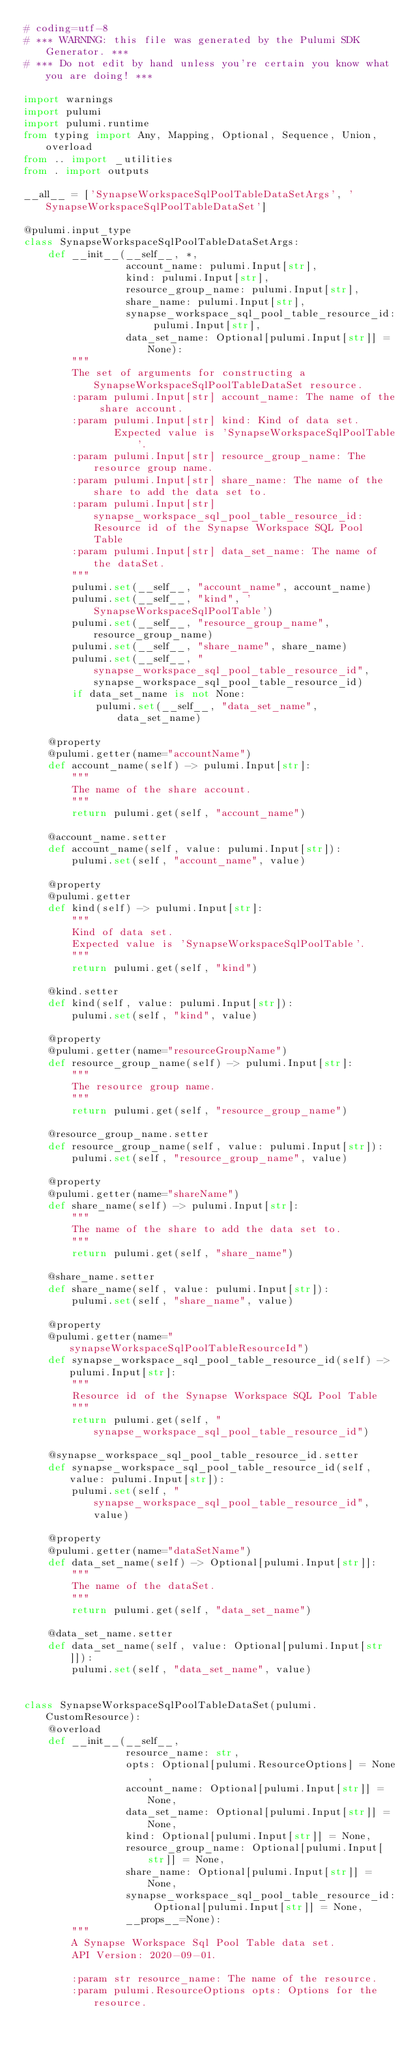Convert code to text. <code><loc_0><loc_0><loc_500><loc_500><_Python_># coding=utf-8
# *** WARNING: this file was generated by the Pulumi SDK Generator. ***
# *** Do not edit by hand unless you're certain you know what you are doing! ***

import warnings
import pulumi
import pulumi.runtime
from typing import Any, Mapping, Optional, Sequence, Union, overload
from .. import _utilities
from . import outputs

__all__ = ['SynapseWorkspaceSqlPoolTableDataSetArgs', 'SynapseWorkspaceSqlPoolTableDataSet']

@pulumi.input_type
class SynapseWorkspaceSqlPoolTableDataSetArgs:
    def __init__(__self__, *,
                 account_name: pulumi.Input[str],
                 kind: pulumi.Input[str],
                 resource_group_name: pulumi.Input[str],
                 share_name: pulumi.Input[str],
                 synapse_workspace_sql_pool_table_resource_id: pulumi.Input[str],
                 data_set_name: Optional[pulumi.Input[str]] = None):
        """
        The set of arguments for constructing a SynapseWorkspaceSqlPoolTableDataSet resource.
        :param pulumi.Input[str] account_name: The name of the share account.
        :param pulumi.Input[str] kind: Kind of data set.
               Expected value is 'SynapseWorkspaceSqlPoolTable'.
        :param pulumi.Input[str] resource_group_name: The resource group name.
        :param pulumi.Input[str] share_name: The name of the share to add the data set to.
        :param pulumi.Input[str] synapse_workspace_sql_pool_table_resource_id: Resource id of the Synapse Workspace SQL Pool Table
        :param pulumi.Input[str] data_set_name: The name of the dataSet.
        """
        pulumi.set(__self__, "account_name", account_name)
        pulumi.set(__self__, "kind", 'SynapseWorkspaceSqlPoolTable')
        pulumi.set(__self__, "resource_group_name", resource_group_name)
        pulumi.set(__self__, "share_name", share_name)
        pulumi.set(__self__, "synapse_workspace_sql_pool_table_resource_id", synapse_workspace_sql_pool_table_resource_id)
        if data_set_name is not None:
            pulumi.set(__self__, "data_set_name", data_set_name)

    @property
    @pulumi.getter(name="accountName")
    def account_name(self) -> pulumi.Input[str]:
        """
        The name of the share account.
        """
        return pulumi.get(self, "account_name")

    @account_name.setter
    def account_name(self, value: pulumi.Input[str]):
        pulumi.set(self, "account_name", value)

    @property
    @pulumi.getter
    def kind(self) -> pulumi.Input[str]:
        """
        Kind of data set.
        Expected value is 'SynapseWorkspaceSqlPoolTable'.
        """
        return pulumi.get(self, "kind")

    @kind.setter
    def kind(self, value: pulumi.Input[str]):
        pulumi.set(self, "kind", value)

    @property
    @pulumi.getter(name="resourceGroupName")
    def resource_group_name(self) -> pulumi.Input[str]:
        """
        The resource group name.
        """
        return pulumi.get(self, "resource_group_name")

    @resource_group_name.setter
    def resource_group_name(self, value: pulumi.Input[str]):
        pulumi.set(self, "resource_group_name", value)

    @property
    @pulumi.getter(name="shareName")
    def share_name(self) -> pulumi.Input[str]:
        """
        The name of the share to add the data set to.
        """
        return pulumi.get(self, "share_name")

    @share_name.setter
    def share_name(self, value: pulumi.Input[str]):
        pulumi.set(self, "share_name", value)

    @property
    @pulumi.getter(name="synapseWorkspaceSqlPoolTableResourceId")
    def synapse_workspace_sql_pool_table_resource_id(self) -> pulumi.Input[str]:
        """
        Resource id of the Synapse Workspace SQL Pool Table
        """
        return pulumi.get(self, "synapse_workspace_sql_pool_table_resource_id")

    @synapse_workspace_sql_pool_table_resource_id.setter
    def synapse_workspace_sql_pool_table_resource_id(self, value: pulumi.Input[str]):
        pulumi.set(self, "synapse_workspace_sql_pool_table_resource_id", value)

    @property
    @pulumi.getter(name="dataSetName")
    def data_set_name(self) -> Optional[pulumi.Input[str]]:
        """
        The name of the dataSet.
        """
        return pulumi.get(self, "data_set_name")

    @data_set_name.setter
    def data_set_name(self, value: Optional[pulumi.Input[str]]):
        pulumi.set(self, "data_set_name", value)


class SynapseWorkspaceSqlPoolTableDataSet(pulumi.CustomResource):
    @overload
    def __init__(__self__,
                 resource_name: str,
                 opts: Optional[pulumi.ResourceOptions] = None,
                 account_name: Optional[pulumi.Input[str]] = None,
                 data_set_name: Optional[pulumi.Input[str]] = None,
                 kind: Optional[pulumi.Input[str]] = None,
                 resource_group_name: Optional[pulumi.Input[str]] = None,
                 share_name: Optional[pulumi.Input[str]] = None,
                 synapse_workspace_sql_pool_table_resource_id: Optional[pulumi.Input[str]] = None,
                 __props__=None):
        """
        A Synapse Workspace Sql Pool Table data set.
        API Version: 2020-09-01.

        :param str resource_name: The name of the resource.
        :param pulumi.ResourceOptions opts: Options for the resource.</code> 